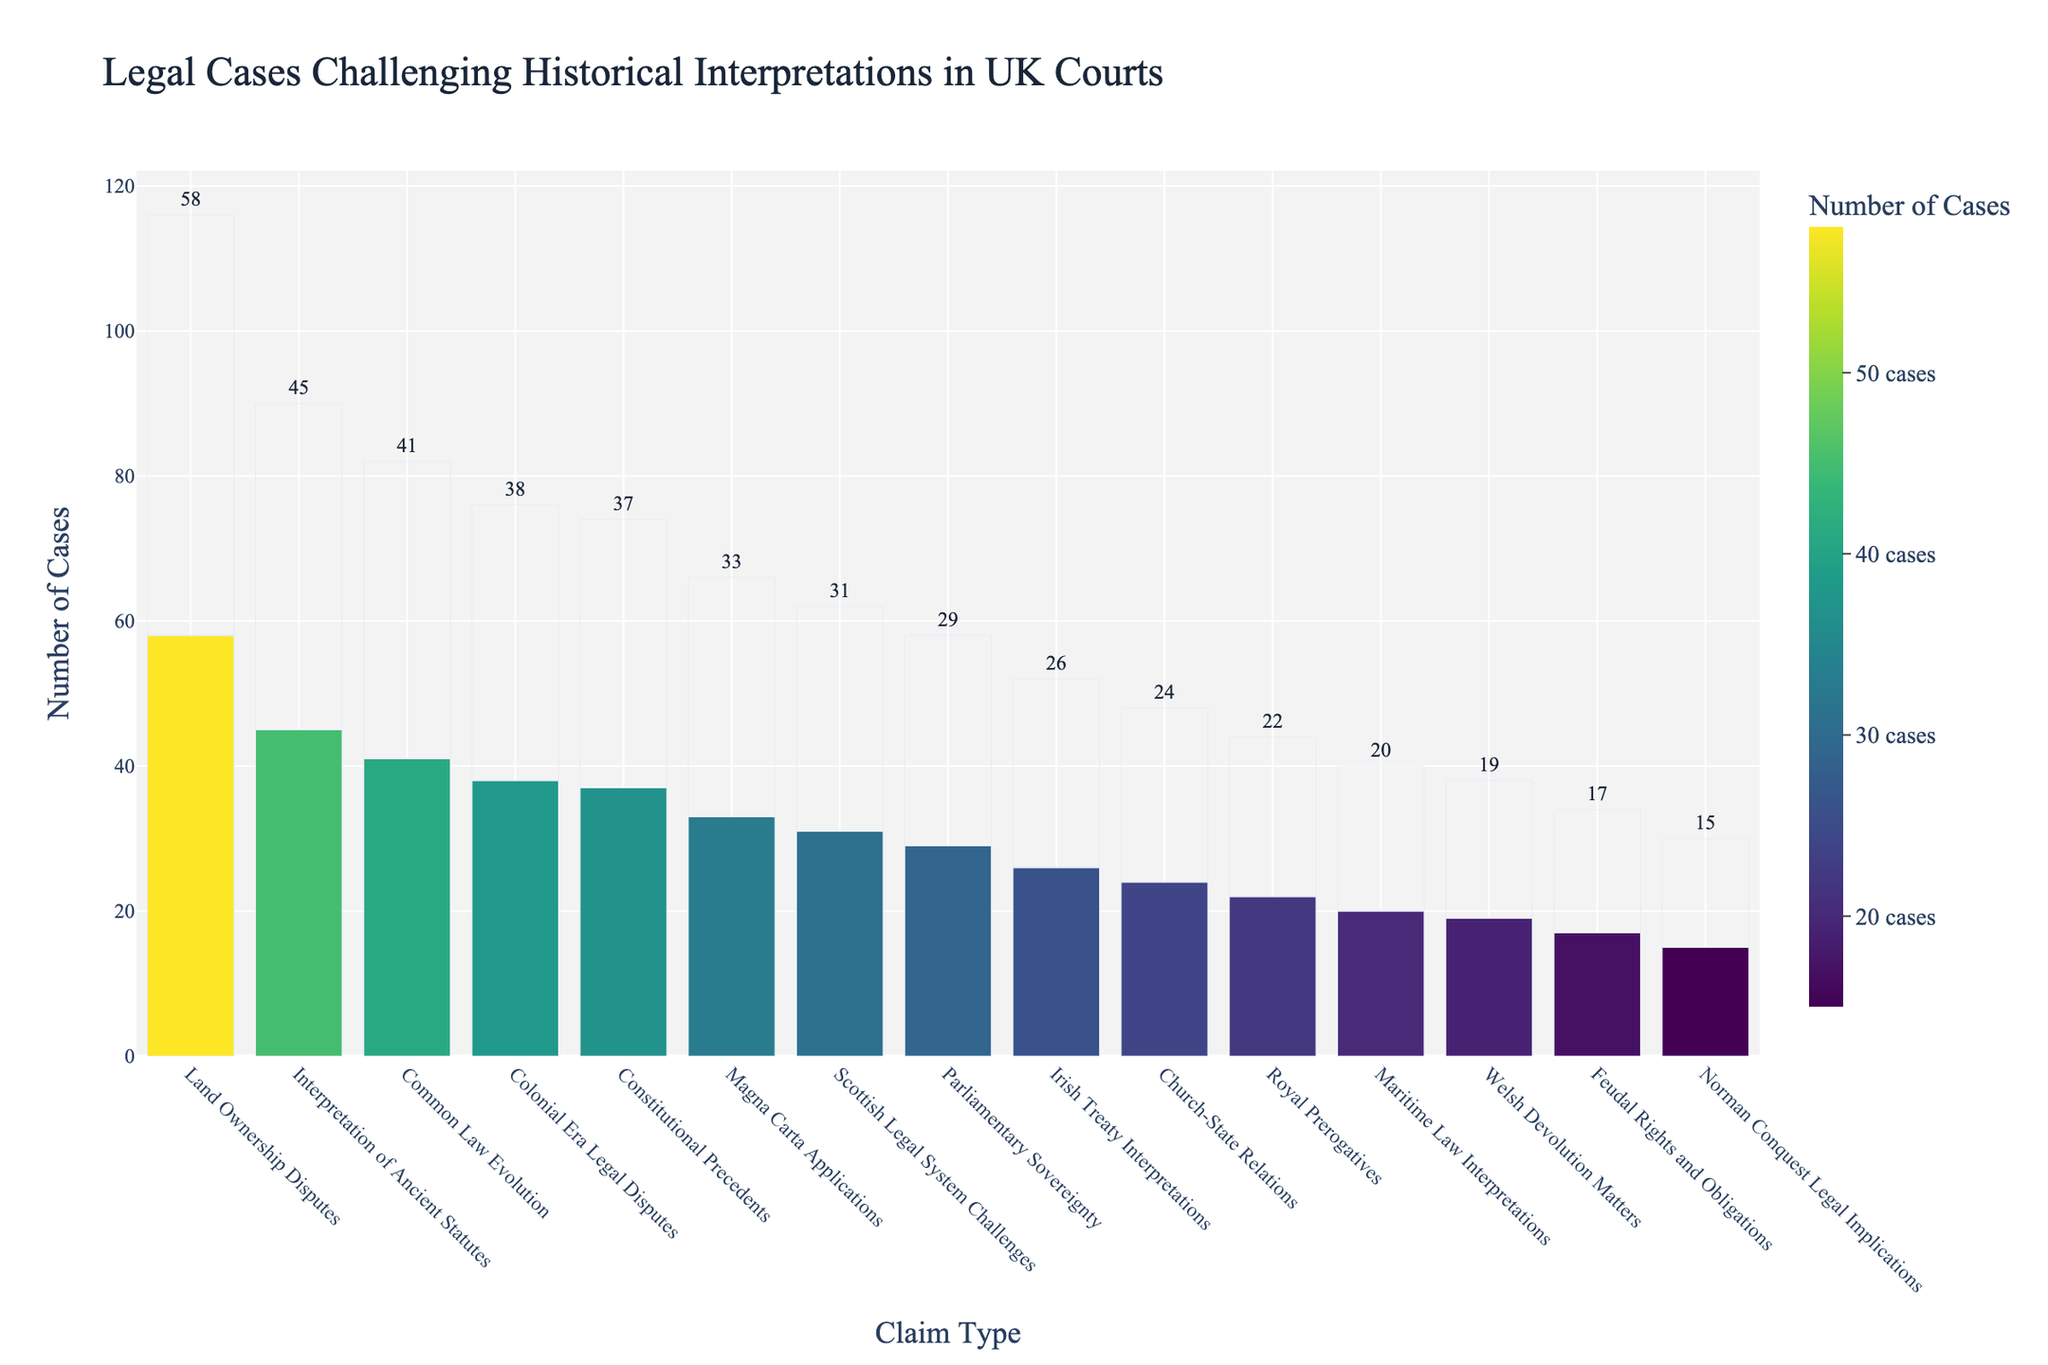Which historical claim type has the highest number of legal cases? The bar chart shows that "Land Ownership Disputes" has the tallest bar, indicating it has the highest number of legal cases.
Answer: Land Ownership Disputes Which historical claim type has the fewest legal cases? The bar for "Norman Conquest Legal Implications" is the shortest, indicating it has the fewest legal cases.
Answer: Norman Conquest Legal Implications What is the total number of legal cases for "Scottish Legal System Challenges" and "Welsh Devolution Matters" combined? From the chart, "Scottish Legal System Challenges" has 31 cases and "Welsh Devolution Matters" has 19 cases. Adding them together gives 31 + 19 = 50 cases.
Answer: 50 cases How does the number of cases for "Common Law Evolution" compare to "Church-State Relations"? The bar for "Common Law Evolution" indicates 41 cases, while "Church-State Relations" shows 24 cases. "Common Law Evolution" has more cases by 41 - 24 = 17 cases.
Answer: 17 more cases Is the number of cases for "Colonial Era Legal Disputes" greater than or less than the number for "Constitutional Precedents"? "Colonial Era Legal Disputes" has 38 cases, and "Constitutional Precedents" has 37 cases. Therefore, "Colonial Era Legal Disputes" has more cases.
Answer: Greater What is the median number of cases across all historical claim types? To find the median, list the number of cases in ascending order: 15, 17, 19, 20, 22, 24, 26, 29, 31, 33, 37, 38, 41, 45, 58. The median value is the middle number, so the 8th value in this ordered list is 29.
Answer: 29 cases By how many cases does "Interpretation of Ancient Statutes" exceed "Parliamentary Sovereignty"? "Interpretation of Ancient Statutes" has 45 cases, and "Parliamentary Sovereignty" has 29 cases. The difference is 45 - 29 = 16 cases.
Answer: 16 cases What percentage of total cases are related to "Magna Carta Applications"? First, sum all the cases: 37 + 22 + 58 + 45 + 31 + 19 + 26 + 33 + 41 + 17 + 29 + 24 + 20 + 38 + 15 = 455. "Magna Carta Applications" has 33 cases. The percentage is (33 / 455) * 100 ≈ 7.25%.
Answer: 7.25% Which historical claim type has a color closer to the yellow end of the color scale? The color scale is a continuous gradient from dark (low number of cases) to bright yellow (high number of cases). "Land Ownership Disputes" is most towards the yellow due to having the highest number of cases (58).
Answer: Land Ownership Disputes 